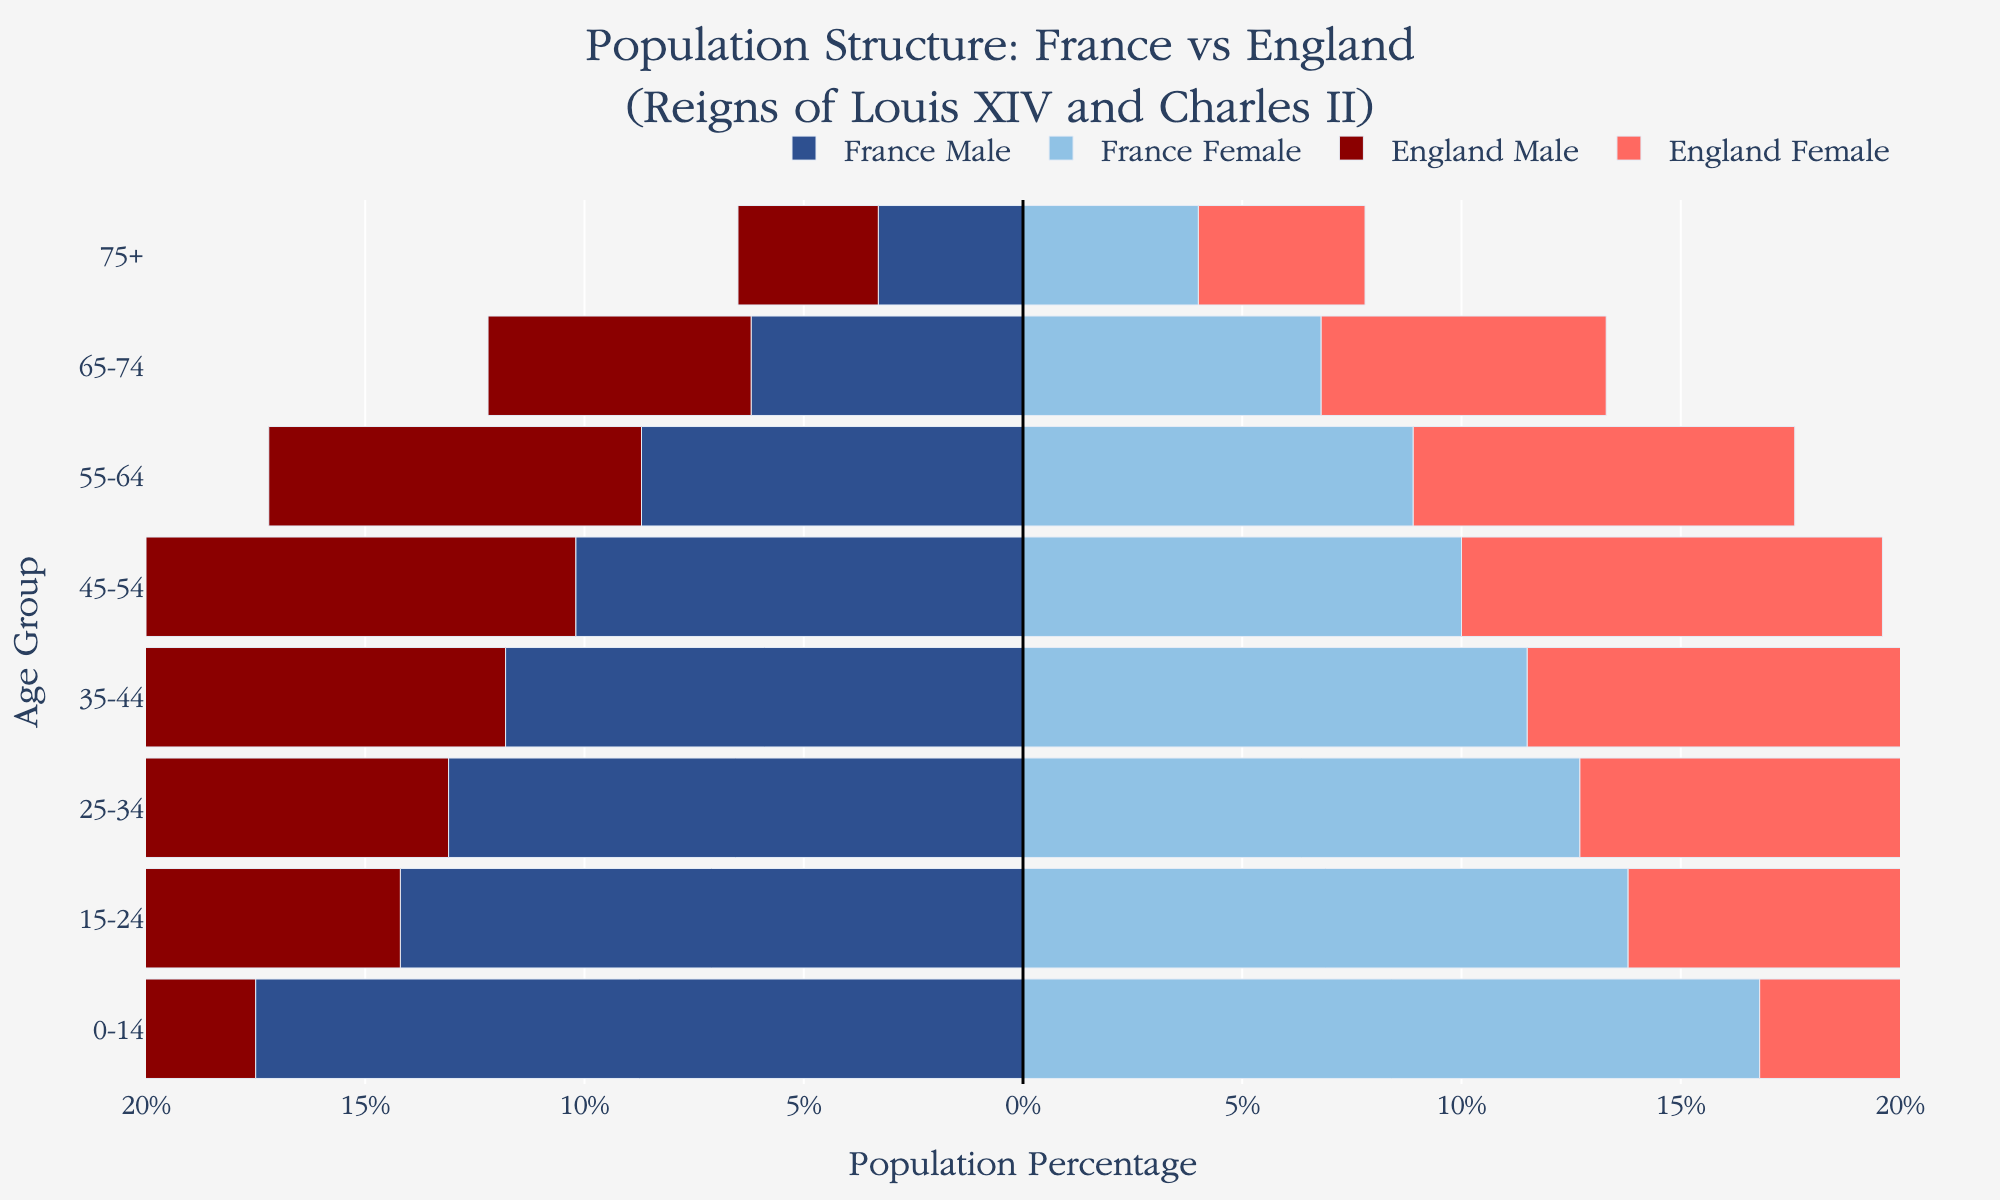What is the largest age group for males in France? The figure indicates population percentages by age groups. For males in France, the largest age group is the 0-14 age group, as it shows the most extended bar at -17.5%.
Answer: 0-14 age group How does the 25-34 age group in England compare for males and females? The figure illustrates population percentages for both genders in age groups. For the 25-34 age group in England, males have a population percentage of -12.8%, whereas females have 12.4%. Therefore, males in this age group slightly outnumber the females.
Answer: Males slightly outnumber females Which country has a higher percentage of population aged 65-74? The figure compares population percentages for the age group 65-74 in both countries. In France, males are at -6.2% and females at 6.8%, while in England, males are at -6.0% and females at 6.5%. Both countries have similar statistics, but France slightly leads with a higher female population in this age group.
Answer: France What is the total percentage of the French population for the age group 15-24? The figure shows that for the age group 15-24 in France, males are at -14.2% and females at 13.8%. Adding these values, the total percentage is 14.2% + 13.8% = 28.0%.
Answer: 28.0% Which gender has a larger population in the 75+ age group in England? The figure indicates population percentages for age groups. In the 75+ age group in England, males are at -3.2% and females at 3.8%. Thus, the female population is larger.
Answer: Females How do the population structures of France and England compare for the 55-64 age group? The figure demonstrates population percentages for the 55-64 age group. In France, males are at -8.7% and females at 8.9%. In England, males are at -8.5% and females at 8.7%. The percentages are quite similar between these two countries, with minor differences favoring France slightly.
Answer: Very similar with minor differences favoring France What is the difference in the population percentage of the 0-14 age group between males in France and males in England? The figure displays population percentages for the 0-14 age group. Males in France are at -17.5%, while males in England are at -16.2%. The difference is calculated as 17.5% - 16.2% = 1.3%.
Answer: 1.3% In which age group do we see the smallest difference between male and female populations in France? By examining the bars in the figure for each age group in France, the smallest difference between male and female populations is in the 45-54 age group where males are at -10.2% and females at 10.0%, showing a difference of 10.2% - 10.0% = 0.2%.
Answer: 45-54 age group Is there any age group where England's male population percentage is higher than France's female population percentage? By comparing the population bars, there is no age group where England's male population percentage surpasses France's female population percentage. England's highest male percentage in 0-14 age group (-16.2%) is still lower than France's corresponding female percentage.
Answer: No 